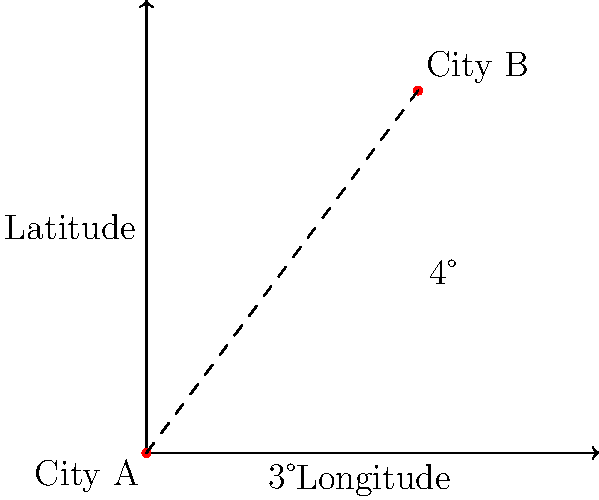A map shows two cities, A and B, using latitude and longitude coordinates. City A is at (0°, 0°), and City B is at (3°E, 4°N). If each degree of latitude or longitude represents 111 km on Earth's surface, what is the approximate distance between these two cities? To solve this problem, we'll use the Pythagorean theorem, as the Earth's surface can be approximated as a plane for small distances.

Step 1: Calculate the distance along the longitude (x-axis).
x = 3° × 111 km/° = 333 km

Step 2: Calculate the distance along the latitude (y-axis).
y = 4° × 111 km/° = 444 km

Step 3: Apply the Pythagorean theorem to find the direct distance.
distance² = x² + y²
distance² = 333² + 444²
distance² = 110,889 + 197,136 = 308,025

Step 4: Take the square root to find the distance.
distance = √308,025 ≈ 555 km

Therefore, the approximate distance between City A and City B is 555 km.
Answer: 555 km 